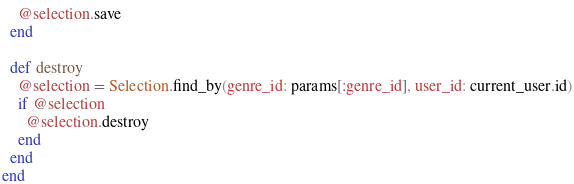Convert code to text. <code><loc_0><loc_0><loc_500><loc_500><_Ruby_>    @selection.save
  end 

  def destroy
    @selection = Selection.find_by(genre_id: params[:genre_id], user_id: current_user.id)
    if @selection
      @selection.destroy
    end
  end
end
</code> 